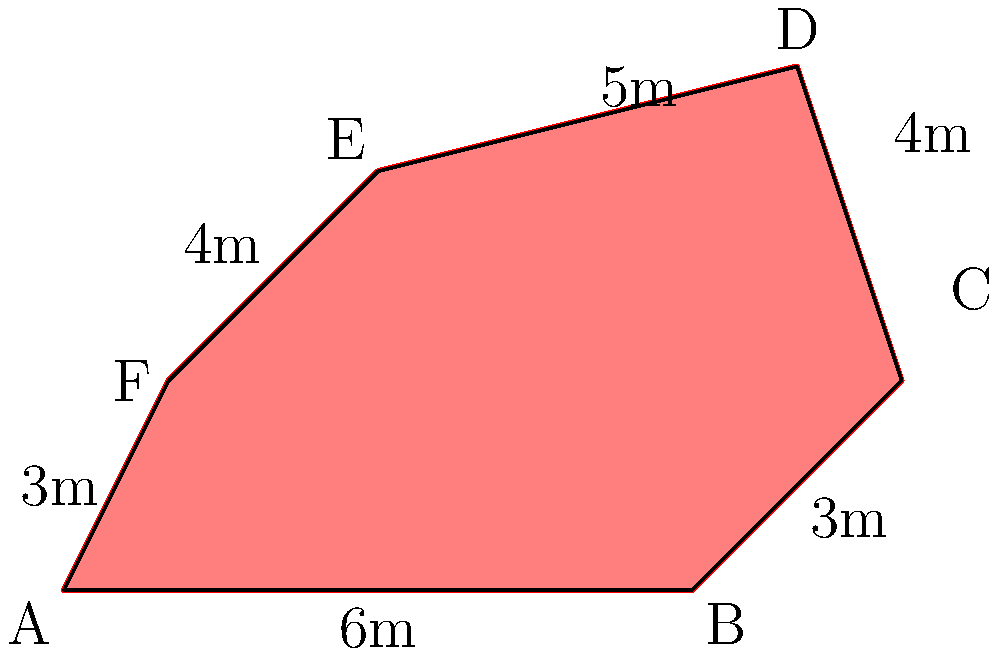As a Red Cross volunteer nurse, you're tasked with assessing the safety of a humanitarian aid route. The route passes near an irregularly shaped minefield represented by the polygon ABCDEF in the diagram. To determine the potential risk area, you need to calculate the total area of the minefield. Given the dimensions shown, what is the area of the minefield in square meters? To calculate the area of this irregular polygon, we can use the shoelace formula (also known as the surveyor's formula). The steps are as follows:

1) First, we need to identify the coordinates of each vertex. From the diagram:
   A(0,0), B(6,0), C(8,2), D(7,5), E(3,4), F(1,2)

2) The shoelace formula for the area of a polygon with vertices $(x_1,y_1), (x_2,y_2), ..., (x_n,y_n)$ is:

   $$Area = \frac{1}{2}|(x_1y_2 + x_2y_3 + ... + x_ny_1) - (y_1x_2 + y_2x_3 + ... + y_nx_1)|$$

3) Applying this formula to our polygon:

   $$\begin{align*}
   Area &= \frac{1}{2}|(0\cdot0 + 6\cdot2 + 8\cdot5 + 7\cdot4 + 3\cdot2 + 1\cdot0) \\
   &\quad - (0\cdot6 + 0\cdot8 + 2\cdot7 + 5\cdot3 + 4\cdot1 + 2\cdot0)|
   \end{align*}$$

4) Simplifying:
   $$\begin{align*}
   Area &= \frac{1}{2}|(0 + 12 + 40 + 28 + 6 + 0) - (0 + 0 + 14 + 15 + 4 + 0)| \\
   &= \frac{1}{2}|86 - 33| \\
   &= \frac{1}{2}|53| \\
   &= \frac{53}{2} \\
   &= 26.5
   \end{align*}$$

Therefore, the area of the minefield is 26.5 square meters.
Answer: 26.5 square meters 